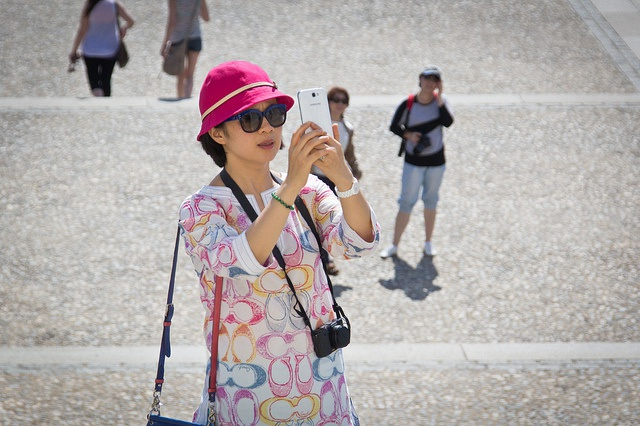Describe the objects in this image and their specific colors. I can see people in darkgray, tan, and lightgray tones, people in darkgray, black, and gray tones, handbag in darkgray, lightgray, navy, and brown tones, people in darkgray, gray, and black tones, and people in darkgray, gray, and black tones in this image. 